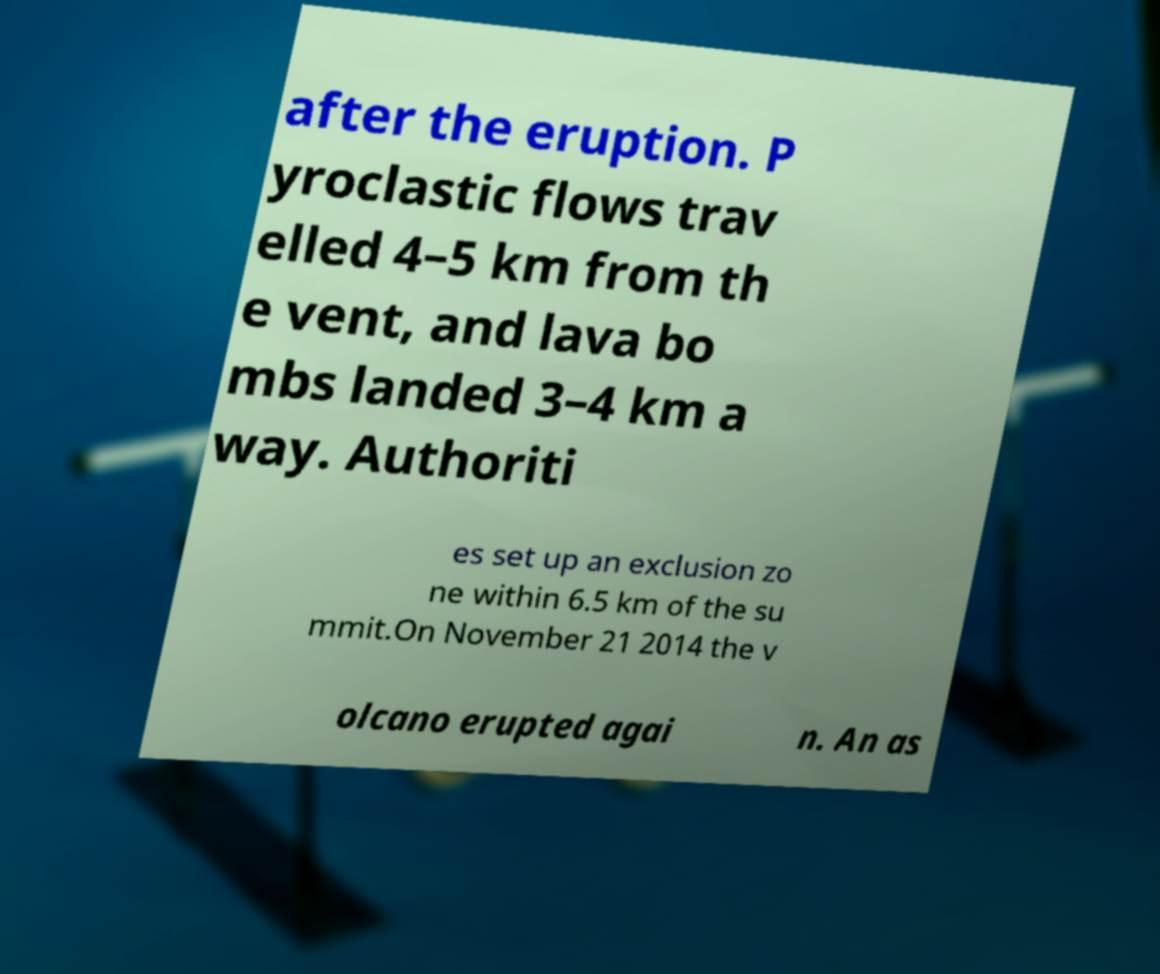I need the written content from this picture converted into text. Can you do that? after the eruption. P yroclastic flows trav elled 4–5 km from th e vent, and lava bo mbs landed 3–4 km a way. Authoriti es set up an exclusion zo ne within 6.5 km of the su mmit.On November 21 2014 the v olcano erupted agai n. An as 